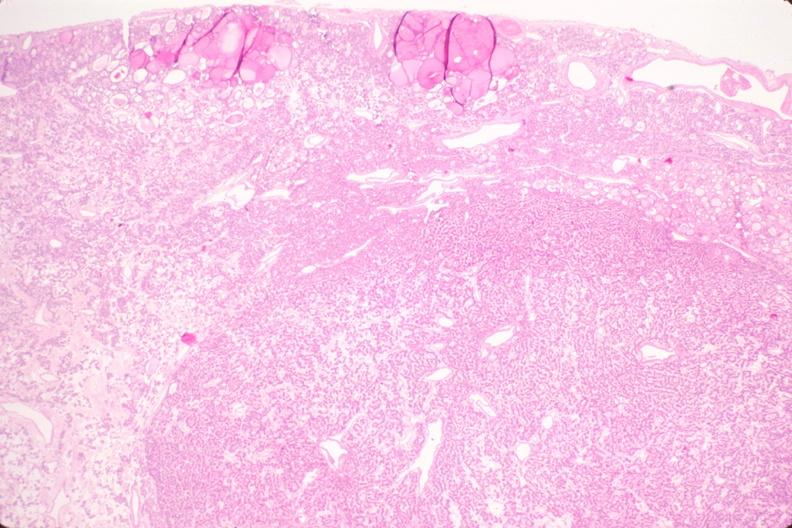what is present?
Answer the question using a single word or phrase. Endocrine 